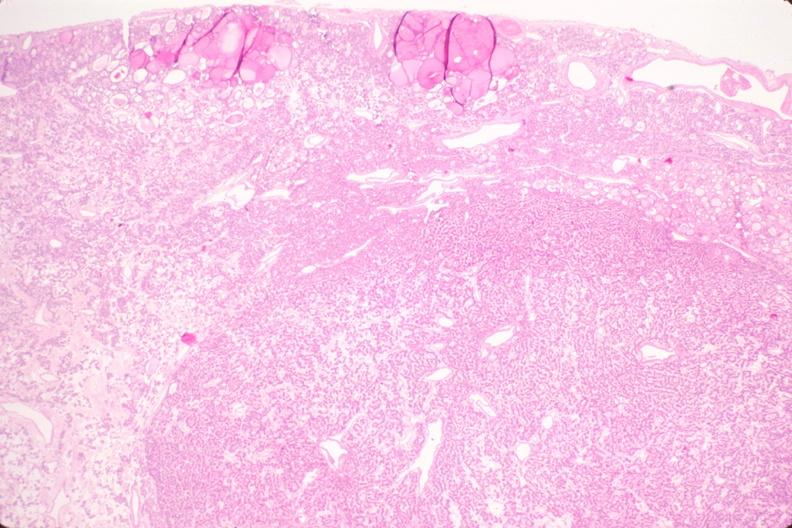what is present?
Answer the question using a single word or phrase. Endocrine 